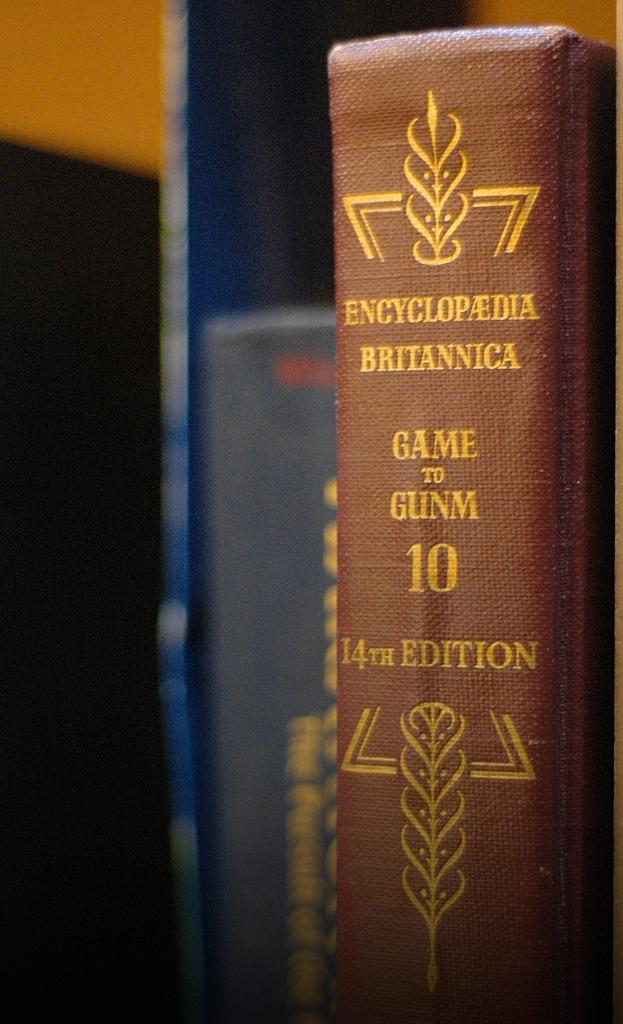<image>
Share a concise interpretation of the image provided. The Encyclopedia Britannica Game to Gunm 14th edition. 